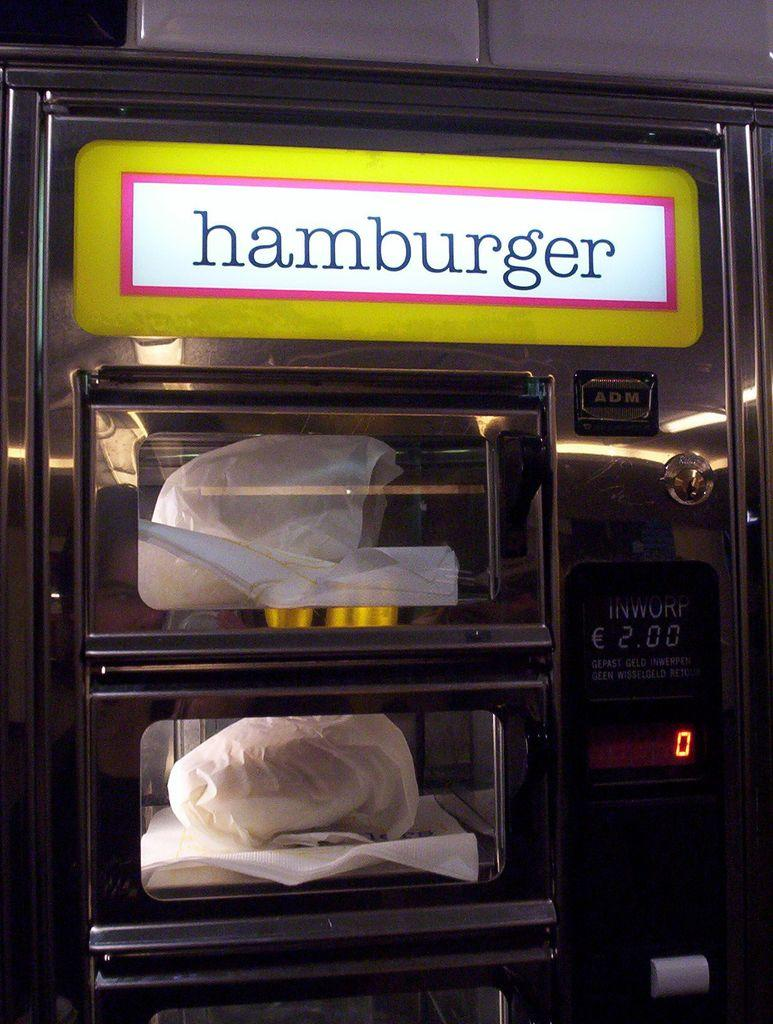Provide a one-sentence caption for the provided image. Hamburger machine from ADM that contains a oven. 